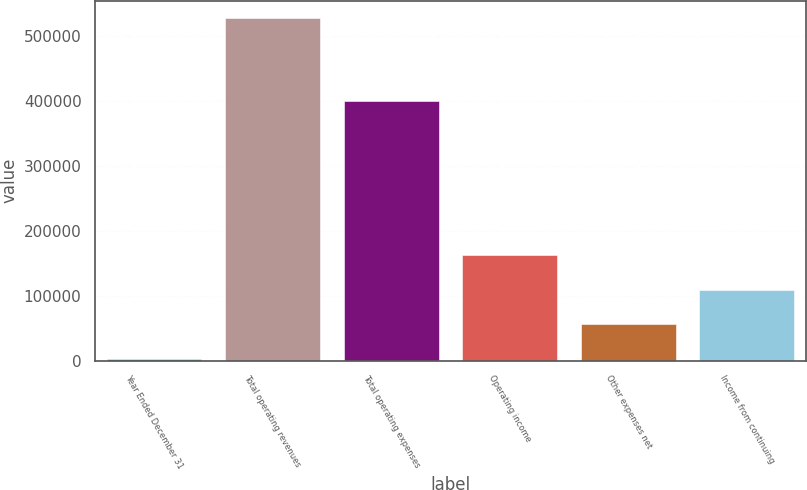<chart> <loc_0><loc_0><loc_500><loc_500><bar_chart><fcel>Year Ended December 31<fcel>Total operating revenues<fcel>Total operating expenses<fcel>Operating income<fcel>Other expenses net<fcel>Income from continuing<nl><fcel>2008<fcel>527445<fcel>400101<fcel>161884<fcel>56797<fcel>109341<nl></chart> 